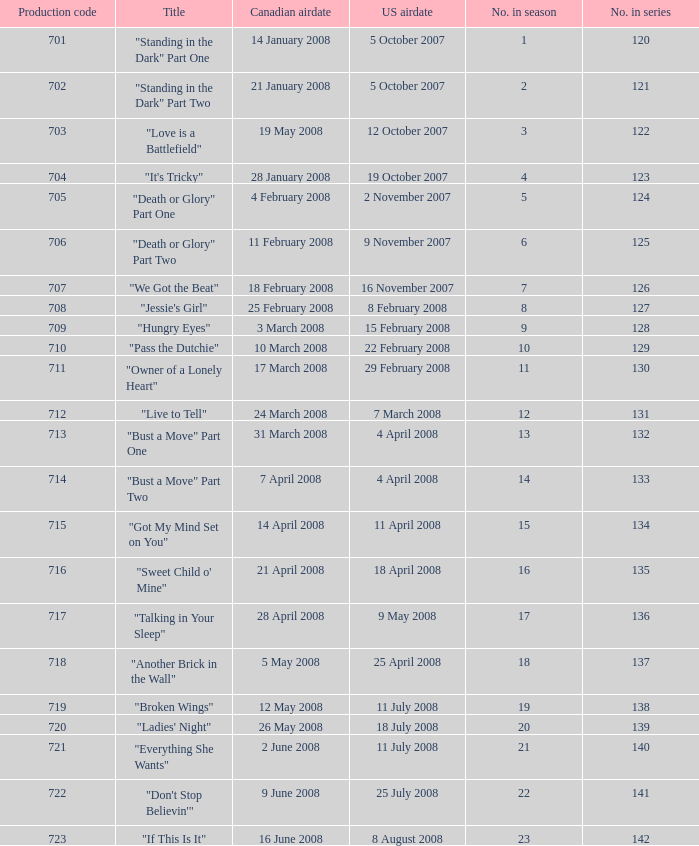The episode titled "don't stop believin'" was what highest number of the season? 22.0. 